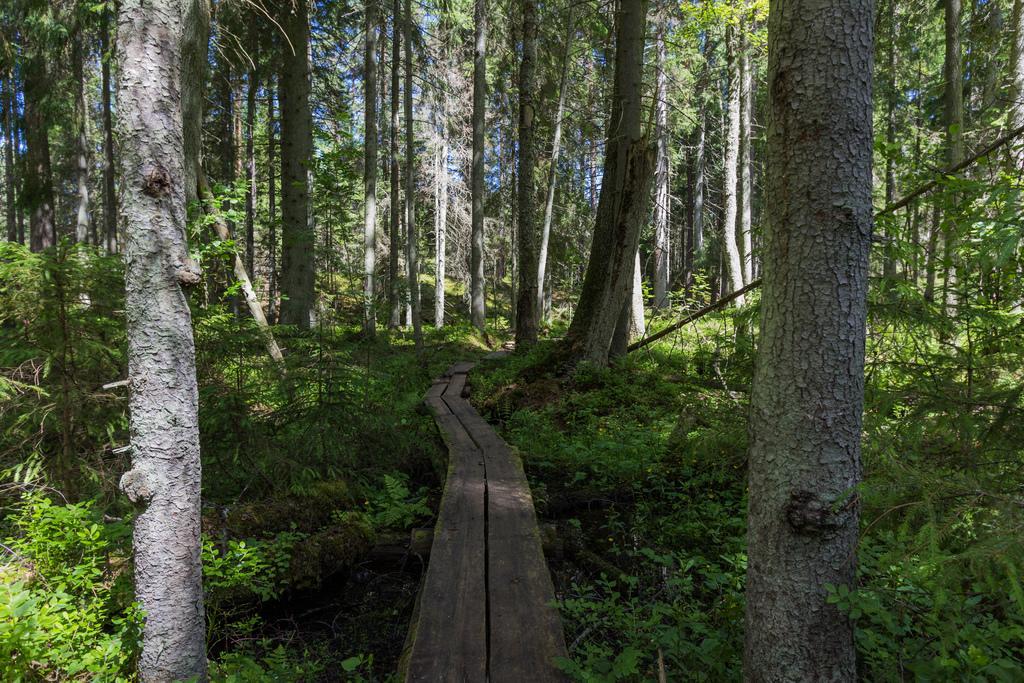In one or two sentences, can you explain what this image depicts? In this picture there is a wooden way in the center of the image and there are trees around the area of the image. 